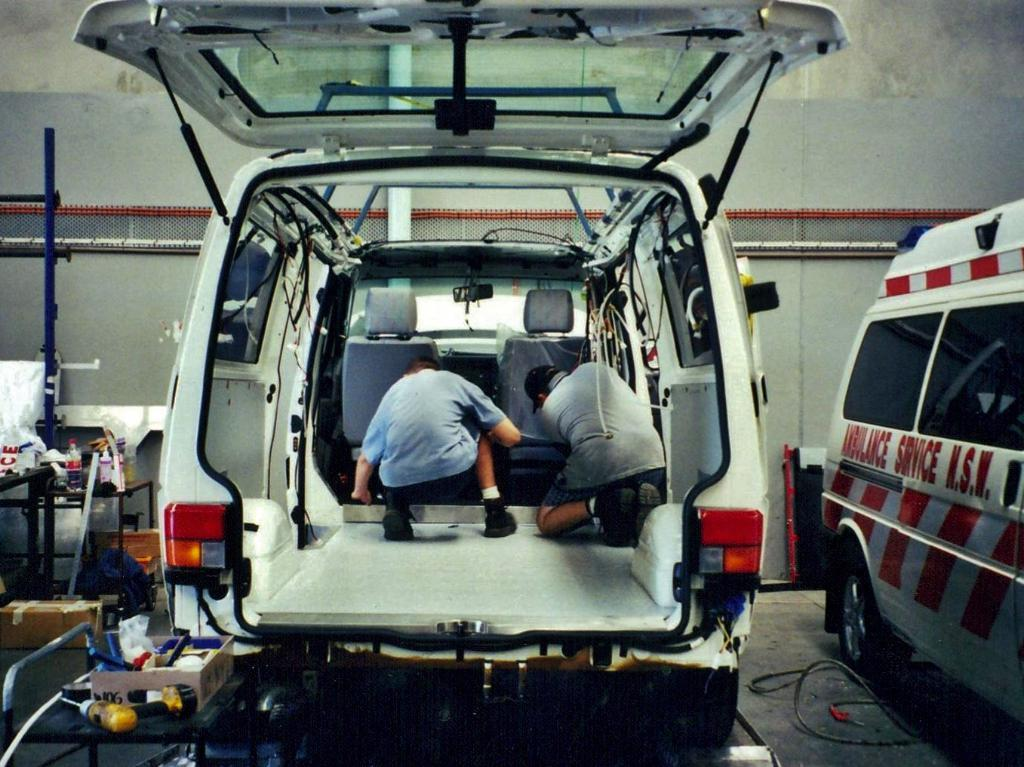What is the main subject of the image? There is a car in the image. Are there any people in the car? Yes, there are two people inside the car. What can be seen beside the first car? There is another car beside the first car. What else is visible in the image besides the cars? There are objects on a desk in the image. What type of glue is being used to hold the bait on the desk in the image? There is no glue or bait present in the image; it only features a car with people inside and another car beside it, as well as objects on a desk. 